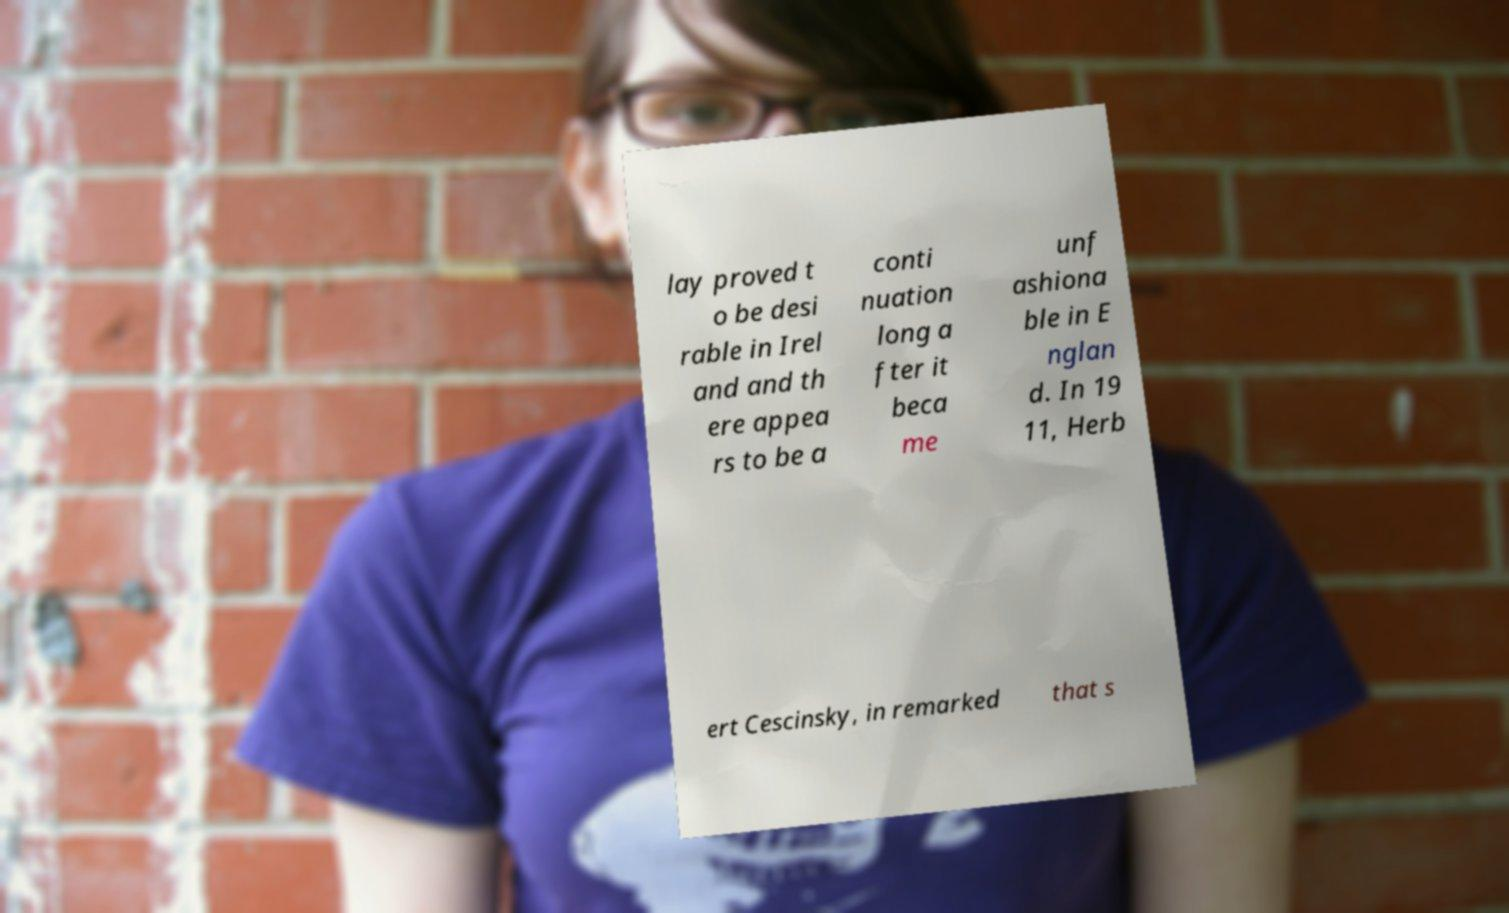Can you read and provide the text displayed in the image?This photo seems to have some interesting text. Can you extract and type it out for me? lay proved t o be desi rable in Irel and and th ere appea rs to be a conti nuation long a fter it beca me unf ashiona ble in E nglan d. In 19 11, Herb ert Cescinsky, in remarked that s 